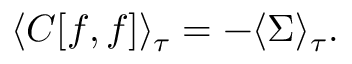<formula> <loc_0><loc_0><loc_500><loc_500>\langle C [ f , f ] \rangle _ { \tau } = - \langle \Sigma \rangle _ { \tau } .</formula> 